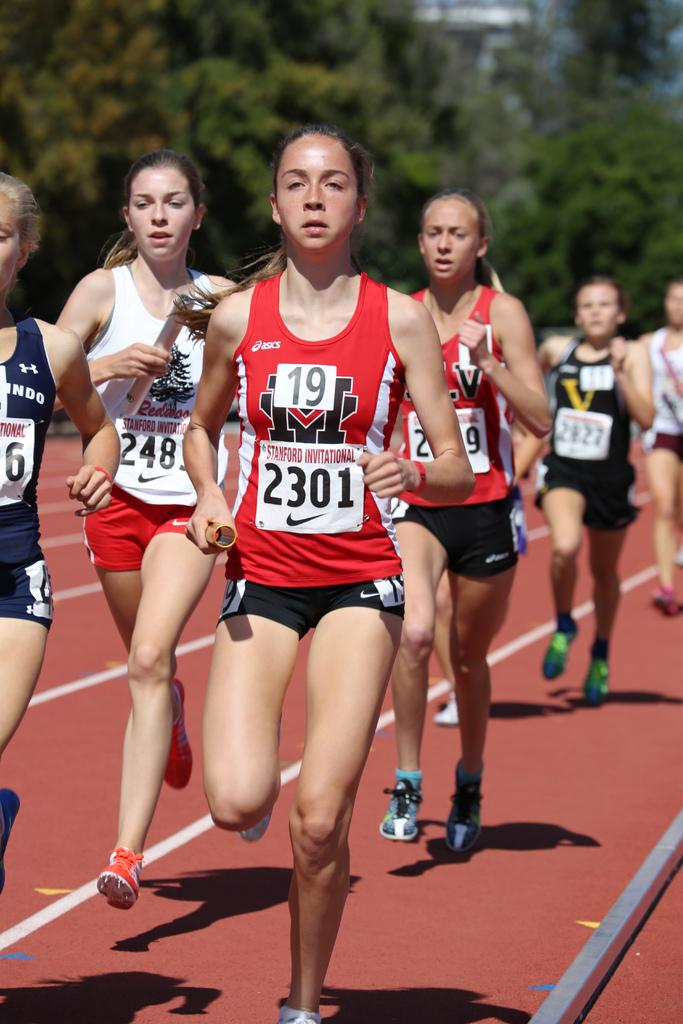Provide a one-sentence caption for the provided image. A group of girls running on a track with the girl in the front wearing a number 19 on her chest. 